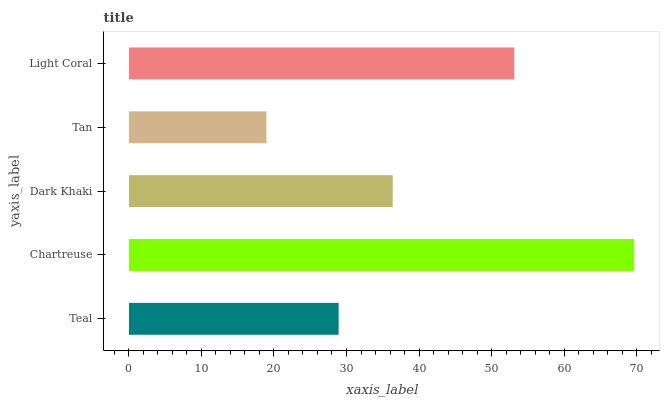Is Tan the minimum?
Answer yes or no. Yes. Is Chartreuse the maximum?
Answer yes or no. Yes. Is Dark Khaki the minimum?
Answer yes or no. No. Is Dark Khaki the maximum?
Answer yes or no. No. Is Chartreuse greater than Dark Khaki?
Answer yes or no. Yes. Is Dark Khaki less than Chartreuse?
Answer yes or no. Yes. Is Dark Khaki greater than Chartreuse?
Answer yes or no. No. Is Chartreuse less than Dark Khaki?
Answer yes or no. No. Is Dark Khaki the high median?
Answer yes or no. Yes. Is Dark Khaki the low median?
Answer yes or no. Yes. Is Tan the high median?
Answer yes or no. No. Is Light Coral the low median?
Answer yes or no. No. 